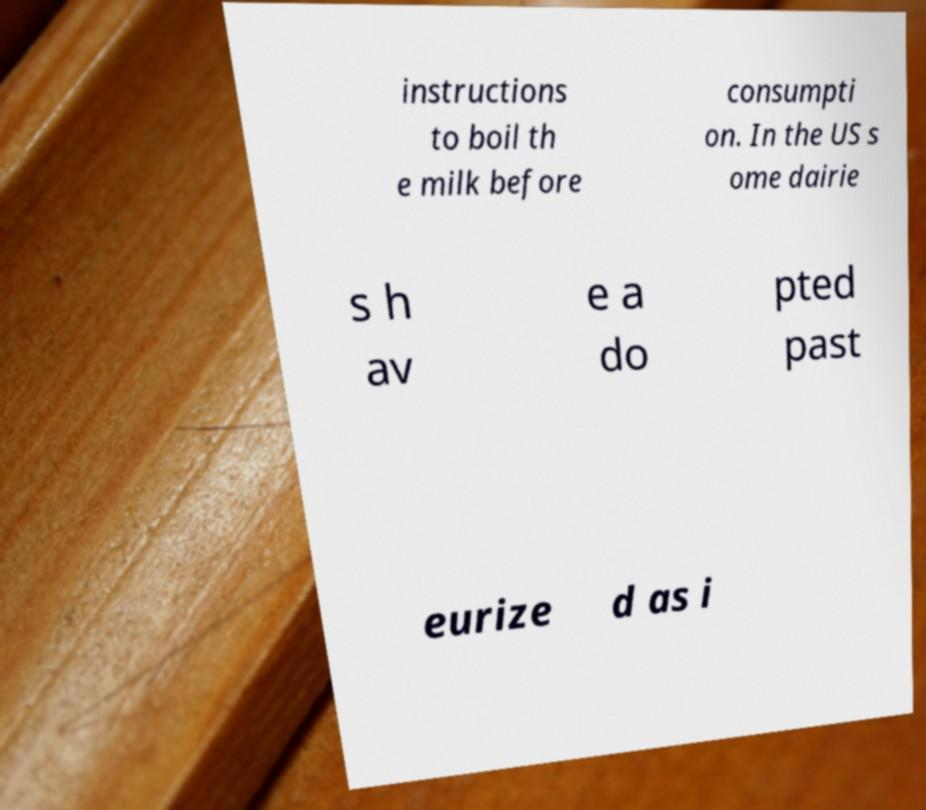Can you read and provide the text displayed in the image?This photo seems to have some interesting text. Can you extract and type it out for me? instructions to boil th e milk before consumpti on. In the US s ome dairie s h av e a do pted past eurize d as i 